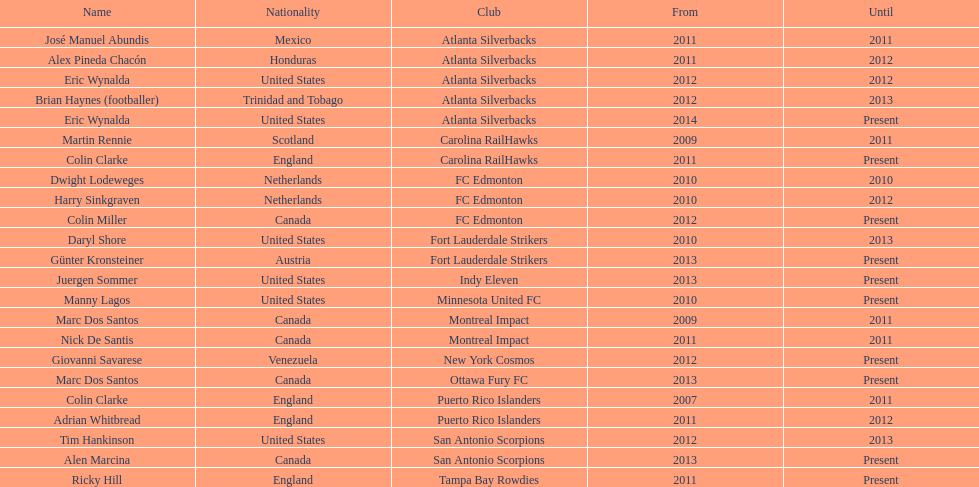Marc dos santos began coaching in the same year as which other coach? Martin Rennie. 